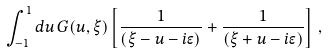Convert formula to latex. <formula><loc_0><loc_0><loc_500><loc_500>\int _ { - 1 } ^ { 1 } d u \, G ( u , \xi ) \left [ \frac { 1 } { ( \xi - u - i \epsilon ) } + \frac { 1 } { ( \xi + u - i \epsilon ) } \right ] \, ,</formula> 